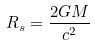Convert formula to latex. <formula><loc_0><loc_0><loc_500><loc_500>R _ { s } = \frac { 2 G M } { c ^ { 2 } }</formula> 